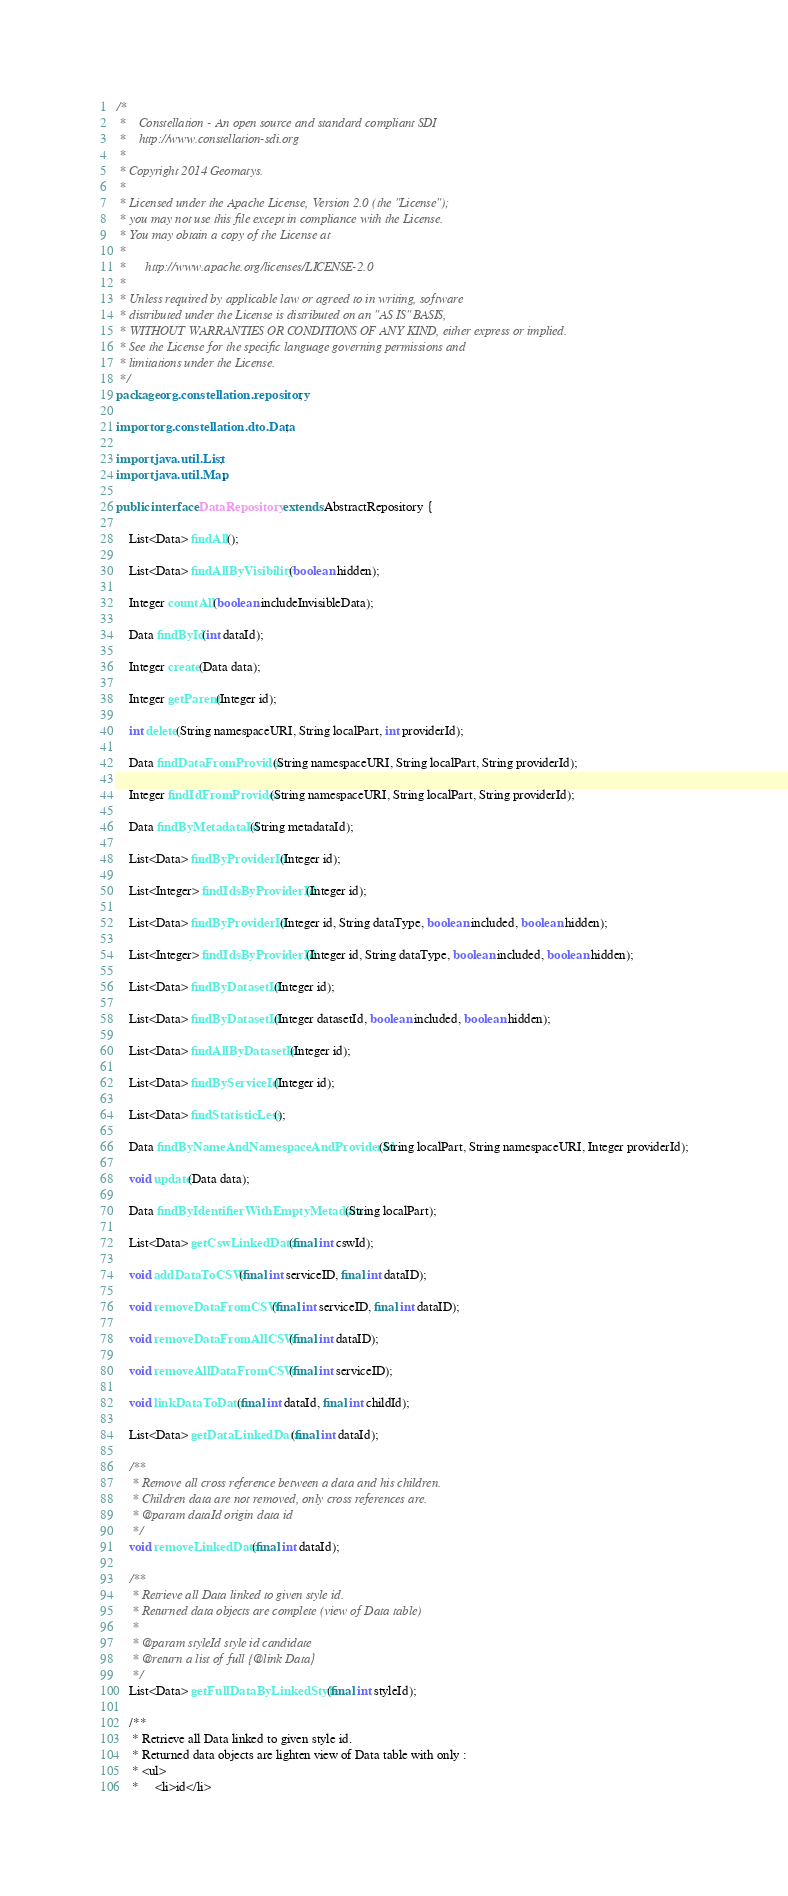Convert code to text. <code><loc_0><loc_0><loc_500><loc_500><_Java_>/*
 *    Constellation - An open source and standard compliant SDI
 *    http://www.constellation-sdi.org
 *
 * Copyright 2014 Geomatys.
 *
 * Licensed under the Apache License, Version 2.0 (the "License");
 * you may not use this file except in compliance with the License.
 * You may obtain a copy of the License at
 *
 *      http://www.apache.org/licenses/LICENSE-2.0
 *
 * Unless required by applicable law or agreed to in writing, software
 * distributed under the License is distributed on an "AS IS" BASIS,
 * WITHOUT WARRANTIES OR CONDITIONS OF ANY KIND, either express or implied.
 * See the License for the specific language governing permissions and
 * limitations under the License.
 */
package org.constellation.repository;

import org.constellation.dto.Data;

import java.util.List;
import java.util.Map;

public interface DataRepository extends AbstractRepository {

    List<Data> findAll();

    List<Data> findAllByVisibility(boolean hidden);

    Integer countAll(boolean includeInvisibleData);

    Data findById(int dataId);

    Integer create(Data data);

    Integer getParent(Integer id);

    int delete(String namespaceURI, String localPart, int providerId);

    Data findDataFromProvider(String namespaceURI, String localPart, String providerId);

    Integer findIdFromProvider(String namespaceURI, String localPart, String providerId);

    Data findByMetadataId(String metadataId);

    List<Data> findByProviderId(Integer id);

    List<Integer> findIdsByProviderId(Integer id);

    List<Data> findByProviderId(Integer id, String dataType, boolean included, boolean hidden);

    List<Integer> findIdsByProviderId(Integer id, String dataType, boolean included, boolean hidden);

    List<Data> findByDatasetId(Integer id);

    List<Data> findByDatasetId(Integer datasetId, boolean included, boolean hidden);

    List<Data> findAllByDatasetId(Integer id);

    List<Data> findByServiceId(Integer id);

    List<Data> findStatisticLess();

    Data findByNameAndNamespaceAndProviderId(String localPart, String namespaceURI, Integer providerId);

    void update(Data data);

    Data findByIdentifierWithEmptyMetadata(String localPart);

    List<Data> getCswLinkedData(final int cswId);

    void addDataToCSW(final int serviceID, final int dataID);

    void removeDataFromCSW(final int serviceID, final int dataID);

    void removeDataFromAllCSW(final int dataID);

    void removeAllDataFromCSW(final int serviceID);

    void linkDataToData(final int dataId, final int childId);

    List<Data> getDataLinkedData(final int dataId);

    /**
     * Remove all cross reference between a data and his children.
     * Children data are not removed, only cross references are.
     * @param dataId origin data id
     */
    void removeLinkedData(final int dataId);

    /**
     * Retrieve all Data linked to given style id.
     * Returned data objects are complete (view of Data table)
     *
     * @param styleId style id candidate
     * @return a list of full {@link Data}
     */
    List<Data> getFullDataByLinkedStyle(final int styleId);

    /**
     * Retrieve all Data linked to given style id.
     * Returned data objects are lighten view of Data table with only :
     * <ul>
     *     <li>id</li></code> 